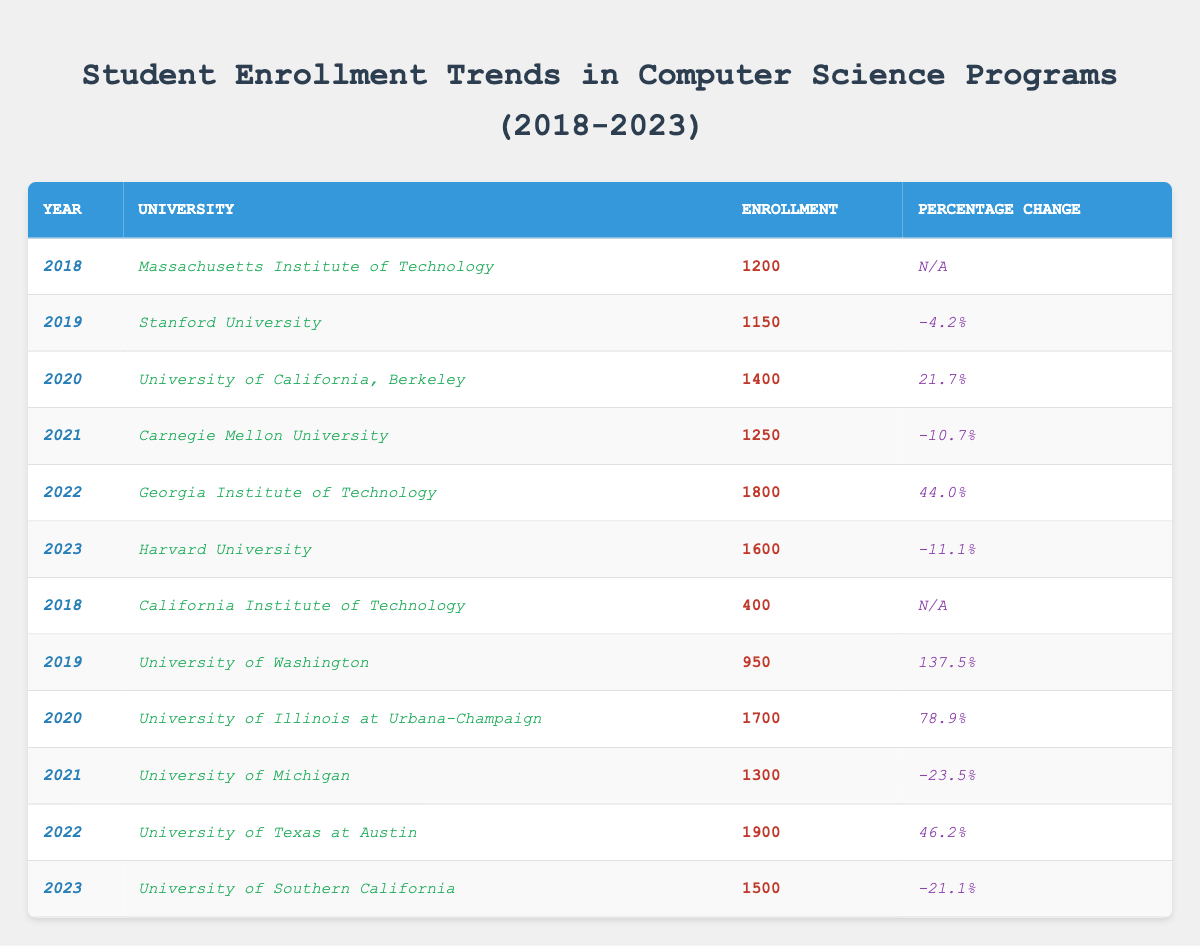What is the total enrollment for the year 2022? The enrollment numbers for 2022 from the universities listed are: Georgia Institute of Technology (1800) and University of Texas at Austin (1900). Adding these gives: 1800 + 1900 = 3700.
Answer: 3700 Which university had the highest enrollment in 2020? In the year 2020, the enrollment numbers are: University of California, Berkeley (1400) and University of Illinois at Urbana-Champaign (1700). The highest number is 1700 from the University of Illinois at Urbana-Champaign.
Answer: University of Illinois at Urbana-Champaign Is there a university that increased its enrollment every year from 2018 to 2022? Looking at the data, from 2018 to 2019, Stanford University decreased its enrollment, and from 2019 to 2020, University of California, Berkeley increased. However, no university shows consistent increases every year. Overall, no university has increased enrollment for all those years.
Answer: No What was the percentage change in enrollment for the University of Washington from 2018 to 2019? The University of Washington's enrollment in 2018 is not listed but in 2019 it is 950, which represents an increase of 137.5% from the previous year. This indicates a significant increase, but without the previous year’s number, we cannot determine the exact value. Based on the percentage, yes, it's a positive change.
Answer: N/A In which year did Georgia Institute of Technology see the largest percentage increase in enrollment? The Georgia Institute of Technology had an enrollment of 1800 in 2022, which represents a 44% increase from the previous year of 2021 (1250). This is the highest increase percentage in the table.
Answer: 2022 Calculate the average enrollment across all universities listed for the year 2023. The total enrollment for 2023 is from Harvard University (1600) and University of Southern California (1500); adding these gives 1600 + 1500 = 3100. There are 2 universities, so we calculate the average: 3100 / 2 = 1550.
Answer: 1550 Which university experienced the lowest enrollment in 2018? In 2018, the universities listed had enrollments of Massachusetts Institute of Technology (1200) and California Institute of Technology (400). 400 is the lowest enrollment for that year.
Answer: California Institute of Technology How did the enrollment numbers for the University of Michigan change between 2021 and 2022? The University of Michigan had an enrollment of 1300 in 2021 and no data for 2022 is provided. Without knowing this value for 2022, we cannot compare. Hence the change cannot be determined.
Answer: Change not determinable What is the total enrollment for the years 2019 and 2021 combined? The total enrollment for 2019 are, Stanford University (1150) and University of Washington (950). In 2021, Carnegie Mellon University had an enrollment of 1250 and University of Michigan had (1300). Adding these together: (1150 + 950) + (1250 + 1300) = 4650.
Answer: 4650 Which university had a negative percentage change in enrollment for 2023? In 2023, Harvard University had a percentage change of -11.1% and University of Southern California had -21.1%. Both experienced a decrease in enrollment.
Answer: Harvard University and University of Southern California What is the average percentage change for all universities listed over the provided years? Calculating the average requires summing the percentage changes where applicable: (N/A ignored) for 2019: -4.2%, 2020: 21.7%, 2021: -10.7%, 2022: 44.0%, 2023: -11.1%. The sum: -4.2 + 21.7 - 10.7 + 44.0 - 11.1 = 39.7, divided by 5 gives an average of 39.7 / 5 = 7.94%.
Answer: 7.94% 